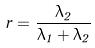Convert formula to latex. <formula><loc_0><loc_0><loc_500><loc_500>r = \frac { \lambda _ { 2 } } { \lambda _ { 1 } + \lambda _ { 2 } }</formula> 